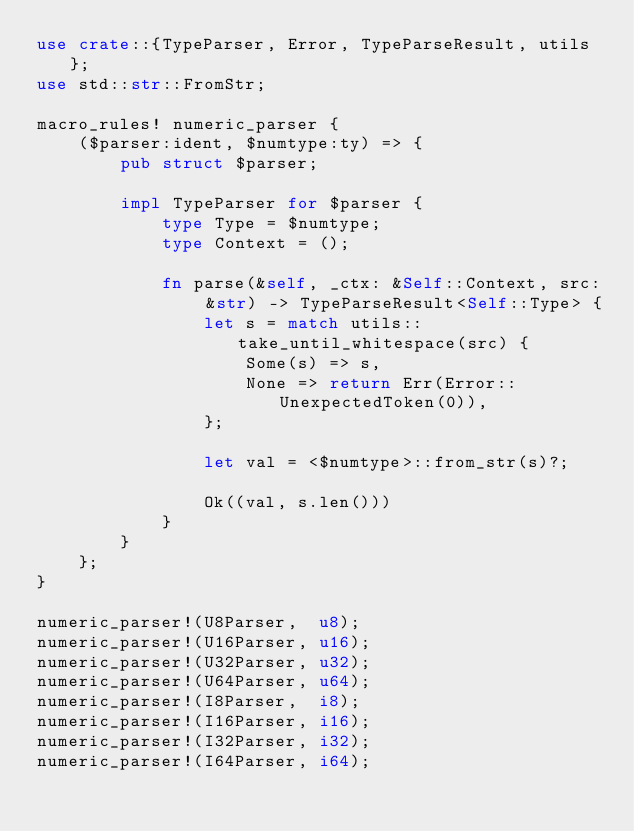<code> <loc_0><loc_0><loc_500><loc_500><_Rust_>use crate::{TypeParser, Error, TypeParseResult, utils};
use std::str::FromStr;

macro_rules! numeric_parser {
    ($parser:ident, $numtype:ty) => {
        pub struct $parser;

        impl TypeParser for $parser {
            type Type = $numtype;
            type Context = ();

            fn parse(&self, _ctx: &Self::Context, src: &str) -> TypeParseResult<Self::Type> {
                let s = match utils::take_until_whitespace(src) {
                    Some(s) => s,
                    None => return Err(Error::UnexpectedToken(0)),
                };

                let val = <$numtype>::from_str(s)?;

                Ok((val, s.len()))
            }
        }
    };
}

numeric_parser!(U8Parser,  u8);
numeric_parser!(U16Parser, u16);
numeric_parser!(U32Parser, u32);
numeric_parser!(U64Parser, u64);
numeric_parser!(I8Parser,  i8);
numeric_parser!(I16Parser, i16);
numeric_parser!(I32Parser, i32);
numeric_parser!(I64Parser, i64);
</code> 